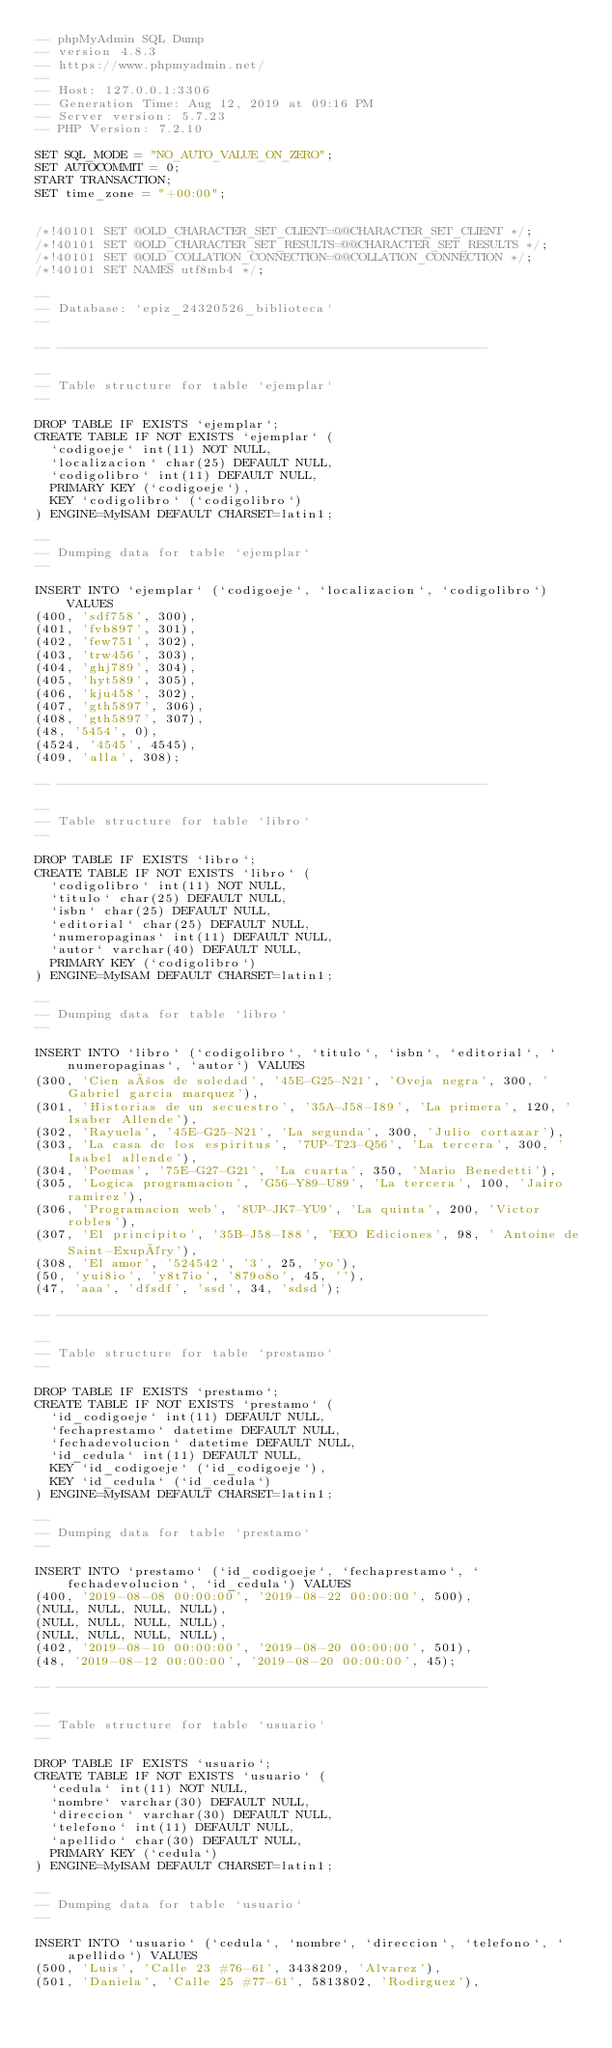Convert code to text. <code><loc_0><loc_0><loc_500><loc_500><_SQL_>-- phpMyAdmin SQL Dump
-- version 4.8.3
-- https://www.phpmyadmin.net/
--
-- Host: 127.0.0.1:3306
-- Generation Time: Aug 12, 2019 at 09:16 PM
-- Server version: 5.7.23
-- PHP Version: 7.2.10

SET SQL_MODE = "NO_AUTO_VALUE_ON_ZERO";
SET AUTOCOMMIT = 0;
START TRANSACTION;
SET time_zone = "+00:00";


/*!40101 SET @OLD_CHARACTER_SET_CLIENT=@@CHARACTER_SET_CLIENT */;
/*!40101 SET @OLD_CHARACTER_SET_RESULTS=@@CHARACTER_SET_RESULTS */;
/*!40101 SET @OLD_COLLATION_CONNECTION=@@COLLATION_CONNECTION */;
/*!40101 SET NAMES utf8mb4 */;

--
-- Database: `epiz_24320526_biblioteca`
--

-- --------------------------------------------------------

--
-- Table structure for table `ejemplar`
--

DROP TABLE IF EXISTS `ejemplar`;
CREATE TABLE IF NOT EXISTS `ejemplar` (
  `codigoeje` int(11) NOT NULL,
  `localizacion` char(25) DEFAULT NULL,
  `codigolibro` int(11) DEFAULT NULL,
  PRIMARY KEY (`codigoeje`),
  KEY `codigolibro` (`codigolibro`)
) ENGINE=MyISAM DEFAULT CHARSET=latin1;

--
-- Dumping data for table `ejemplar`
--

INSERT INTO `ejemplar` (`codigoeje`, `localizacion`, `codigolibro`) VALUES
(400, 'sdf758', 300),
(401, 'fvb897', 301),
(402, 'few751', 302),
(403, 'trw456', 303),
(404, 'ghj789', 304),
(405, 'hyt589', 305),
(406, 'kju458', 302),
(407, 'gth5897', 306),
(408, 'gth5897', 307),
(48, '5454', 0),
(4524, '4545', 4545),
(409, 'alla', 308);

-- --------------------------------------------------------

--
-- Table structure for table `libro`
--

DROP TABLE IF EXISTS `libro`;
CREATE TABLE IF NOT EXISTS `libro` (
  `codigolibro` int(11) NOT NULL,
  `titulo` char(25) DEFAULT NULL,
  `isbn` char(25) DEFAULT NULL,
  `editorial` char(25) DEFAULT NULL,
  `numeropaginas` int(11) DEFAULT NULL,
  `autor` varchar(40) DEFAULT NULL,
  PRIMARY KEY (`codigolibro`)
) ENGINE=MyISAM DEFAULT CHARSET=latin1;

--
-- Dumping data for table `libro`
--

INSERT INTO `libro` (`codigolibro`, `titulo`, `isbn`, `editorial`, `numeropaginas`, `autor`) VALUES
(300, 'Cien años de soledad', '45E-G25-N21', 'Oveja negra', 300, ' Gabriel garcia marquez'),
(301, 'Historias de un secuestro', '35A-J58-I89', 'La primera', 120, 'Isaber Allende'),
(302, 'Rayuela', '45E-G25-N21', 'La segunda', 300, 'Julio cortazar'),
(303, 'La casa de los espiritus', '7UP-T23-Q56', 'La tercera', 300, 'Isabel allende'),
(304, 'Poemas', '75E-G27-G21', 'La cuarta', 350, 'Mario Benedetti'),
(305, 'Logica programacion', 'G56-Y89-U89', 'La tercera', 100, 'Jairo ramirez'),
(306, 'Programacion web', '8UP-JK7-YU9', 'La quinta', 200, 'Victor robles'),
(307, 'El principito', '35B-J58-I88', 'ECO Ediciones', 98, ' Antoine de Saint-Exupéry'),
(308, 'El amor', '524542', '3', 25, 'yo'),
(50, 'yui8io', 'y8t7io', '879o8o', 45, ''),
(47, 'aaa', 'dfsdf', 'ssd', 34, 'sdsd');

-- --------------------------------------------------------

--
-- Table structure for table `prestamo`
--

DROP TABLE IF EXISTS `prestamo`;
CREATE TABLE IF NOT EXISTS `prestamo` (
  `id_codigoeje` int(11) DEFAULT NULL,
  `fechaprestamo` datetime DEFAULT NULL,
  `fechadevolucion` datetime DEFAULT NULL,
  `id_cedula` int(11) DEFAULT NULL,
  KEY `id_codigoeje` (`id_codigoeje`),
  KEY `id_cedula` (`id_cedula`)
) ENGINE=MyISAM DEFAULT CHARSET=latin1;

--
-- Dumping data for table `prestamo`
--

INSERT INTO `prestamo` (`id_codigoeje`, `fechaprestamo`, `fechadevolucion`, `id_cedula`) VALUES
(400, '2019-08-08 00:00:00', '2019-08-22 00:00:00', 500),
(NULL, NULL, NULL, NULL),
(NULL, NULL, NULL, NULL),
(NULL, NULL, NULL, NULL),
(402, '2019-08-10 00:00:00', '2019-08-20 00:00:00', 501),
(48, '2019-08-12 00:00:00', '2019-08-20 00:00:00', 45);

-- --------------------------------------------------------

--
-- Table structure for table `usuario`
--

DROP TABLE IF EXISTS `usuario`;
CREATE TABLE IF NOT EXISTS `usuario` (
  `cedula` int(11) NOT NULL,
  `nombre` varchar(30) DEFAULT NULL,
  `direccion` varchar(30) DEFAULT NULL,
  `telefono` int(11) DEFAULT NULL,
  `apellido` char(30) DEFAULT NULL,
  PRIMARY KEY (`cedula`)
) ENGINE=MyISAM DEFAULT CHARSET=latin1;

--
-- Dumping data for table `usuario`
--

INSERT INTO `usuario` (`cedula`, `nombre`, `direccion`, `telefono`, `apellido`) VALUES
(500, 'Luis', 'Calle 23 #76-61', 3438209, 'Alvarez'),
(501, 'Daniela', 'Calle 25 #77-61', 5813802, 'Rodirguez'),</code> 